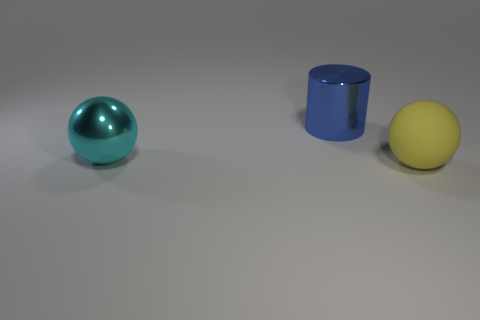Add 3 purple cylinders. How many objects exist? 6 Subtract all cylinders. How many objects are left? 2 Add 1 big blue metallic cylinders. How many big blue metallic cylinders are left? 2 Add 3 small purple balls. How many small purple balls exist? 3 Subtract 0 red cylinders. How many objects are left? 3 Subtract all purple matte things. Subtract all metal things. How many objects are left? 1 